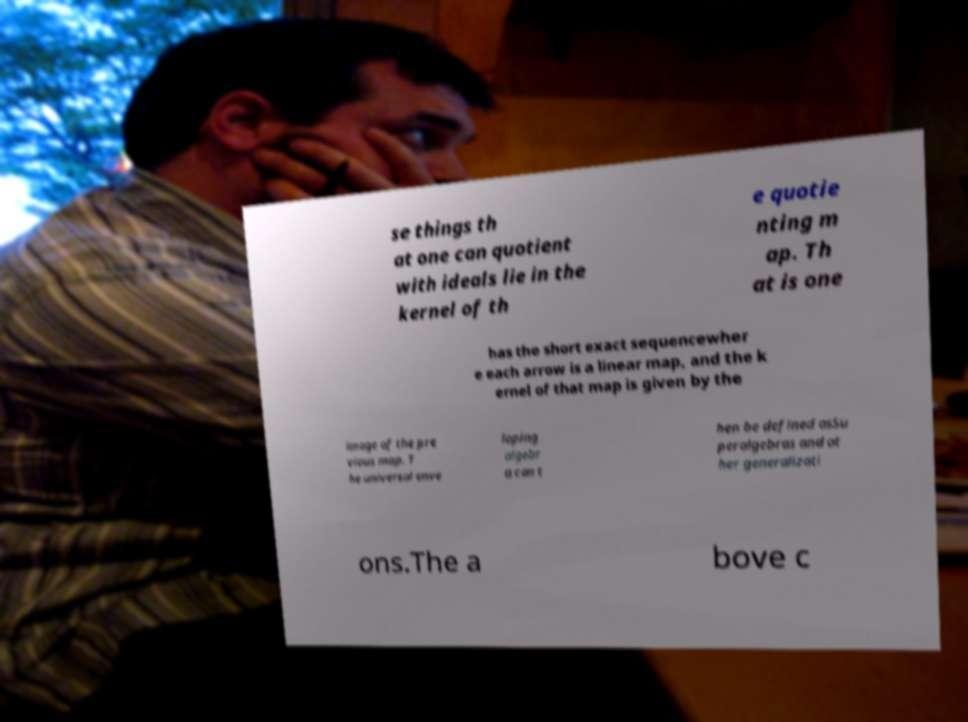For documentation purposes, I need the text within this image transcribed. Could you provide that? se things th at one can quotient with ideals lie in the kernel of th e quotie nting m ap. Th at is one has the short exact sequencewher e each arrow is a linear map, and the k ernel of that map is given by the image of the pre vious map. T he universal enve loping algebr a can t hen be defined asSu peralgebras and ot her generalizati ons.The a bove c 